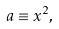<formula> <loc_0><loc_0><loc_500><loc_500>a \equiv x ^ { 2 } ,</formula> 